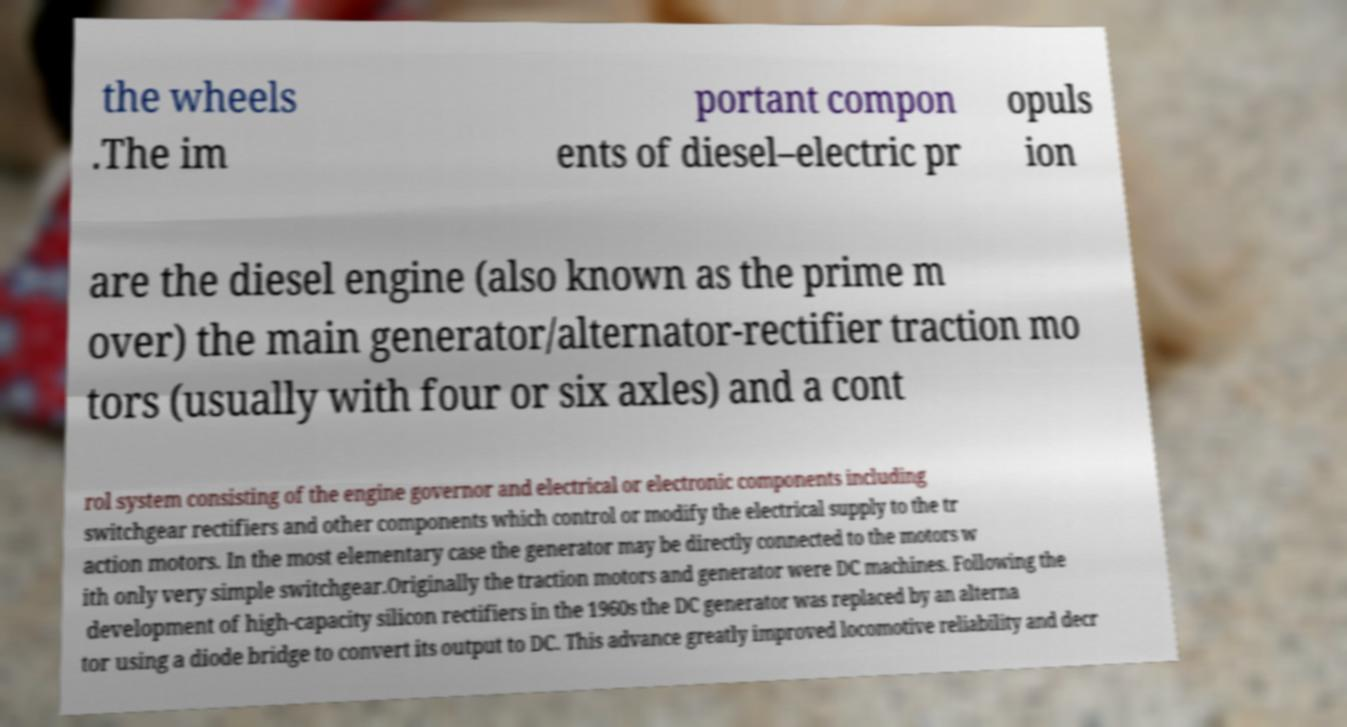Please identify and transcribe the text found in this image. the wheels .The im portant compon ents of diesel–electric pr opuls ion are the diesel engine (also known as the prime m over) the main generator/alternator-rectifier traction mo tors (usually with four or six axles) and a cont rol system consisting of the engine governor and electrical or electronic components including switchgear rectifiers and other components which control or modify the electrical supply to the tr action motors. In the most elementary case the generator may be directly connected to the motors w ith only very simple switchgear.Originally the traction motors and generator were DC machines. Following the development of high-capacity silicon rectifiers in the 1960s the DC generator was replaced by an alterna tor using a diode bridge to convert its output to DC. This advance greatly improved locomotive reliability and decr 